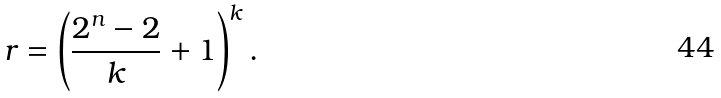<formula> <loc_0><loc_0><loc_500><loc_500>r = \left ( \frac { 2 ^ { n } - 2 } { k } + 1 \right ) ^ { k } .</formula> 